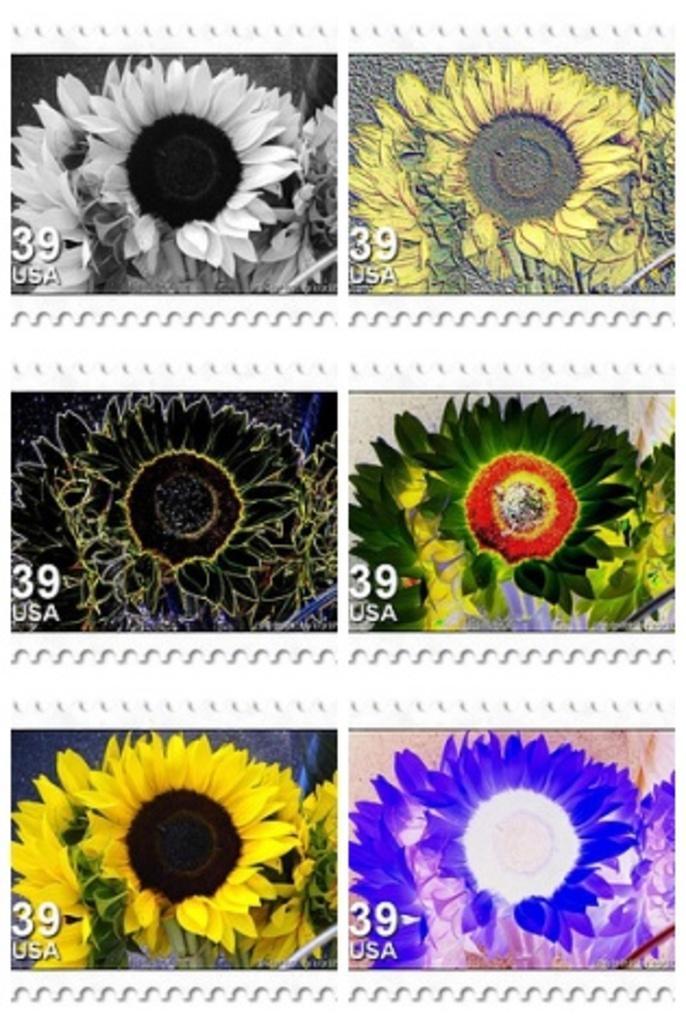How would you summarize this image in a sentence or two? This is a collage picture and in this picture we can see flowers of different colors and some text. 